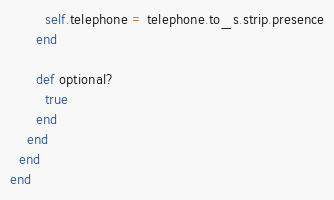Convert code to text. <code><loc_0><loc_0><loc_500><loc_500><_Ruby_>        self.telephone = telephone.to_s.strip.presence
      end

      def optional?
        true
      end
    end
  end
end
</code> 